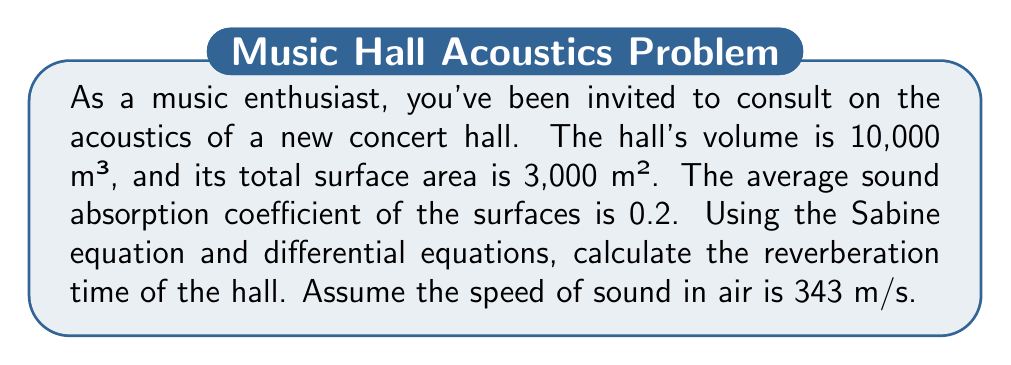Could you help me with this problem? Let's approach this step-by-step:

1) The Sabine equation for reverberation time is:

   $$T = \frac{0.161V}{A}$$

   where $T$ is the reverberation time in seconds, $V$ is the volume of the room in cubic meters, and $A$ is the total absorption in sabins.

2) We need to find $A$. The total absorption is given by:

   $$A = \alpha S$$

   where $\alpha$ is the average absorption coefficient and $S$ is the total surface area.

3) Given:
   - $V = 10,000$ m³
   - $S = 3,000$ m²
   - $\alpha = 0.2$

4) Calculate $A$:
   $$A = 0.2 \times 3,000 = 600$$ sabins

5) Now we can use the Sabine equation:

   $$T = \frac{0.161 \times 10,000}{600} = 2.68$$ seconds

6) To relate this to differential equations, we can model the decay of sound energy in the room. Let $E(t)$ be the sound energy at time $t$. The rate of change of energy is proportional to the energy present:

   $$\frac{dE}{dt} = -kE$$

   where $k$ is a constant related to the absorption properties of the room.

7) The solution to this differential equation is:

   $$E(t) = E_0e^{-kt}$$

   where $E_0$ is the initial energy.

8) The reverberation time is defined as the time it takes for the sound energy to decay by 60 dB, which is a factor of $10^{-6}$. So we need to solve:

   $$E_0e^{-kT} = 10^{-6}E_0$$

9) Taking the natural log of both sides:

   $$-kT = \ln(10^{-6}) = -13.82$$

10) Therefore:

    $$T = \frac{13.82}{k}$$

11) Comparing this with our Sabine equation result, we can see that:

    $$k = \frac{13.82}{2.68} = 5.16$$ s⁻¹

This shows how the differential equation approach relates to the Sabine equation result.
Answer: 2.68 seconds 